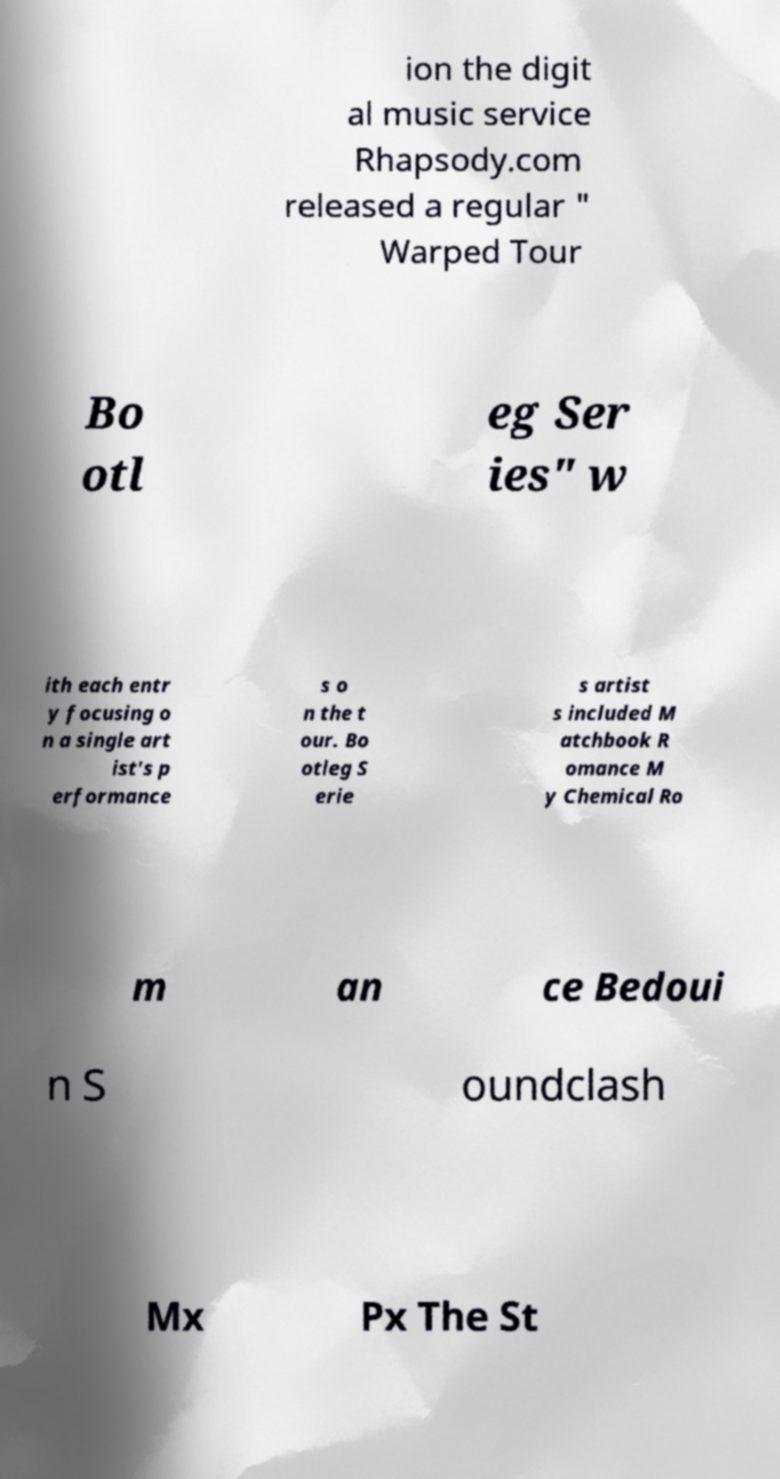Could you assist in decoding the text presented in this image and type it out clearly? ion the digit al music service Rhapsody.com released a regular " Warped Tour Bo otl eg Ser ies" w ith each entr y focusing o n a single art ist's p erformance s o n the t our. Bo otleg S erie s artist s included M atchbook R omance M y Chemical Ro m an ce Bedoui n S oundclash Mx Px The St 